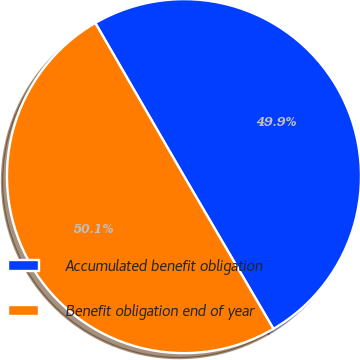<chart> <loc_0><loc_0><loc_500><loc_500><pie_chart><fcel>Accumulated benefit obligation<fcel>Benefit obligation end of year<nl><fcel>49.92%<fcel>50.08%<nl></chart> 